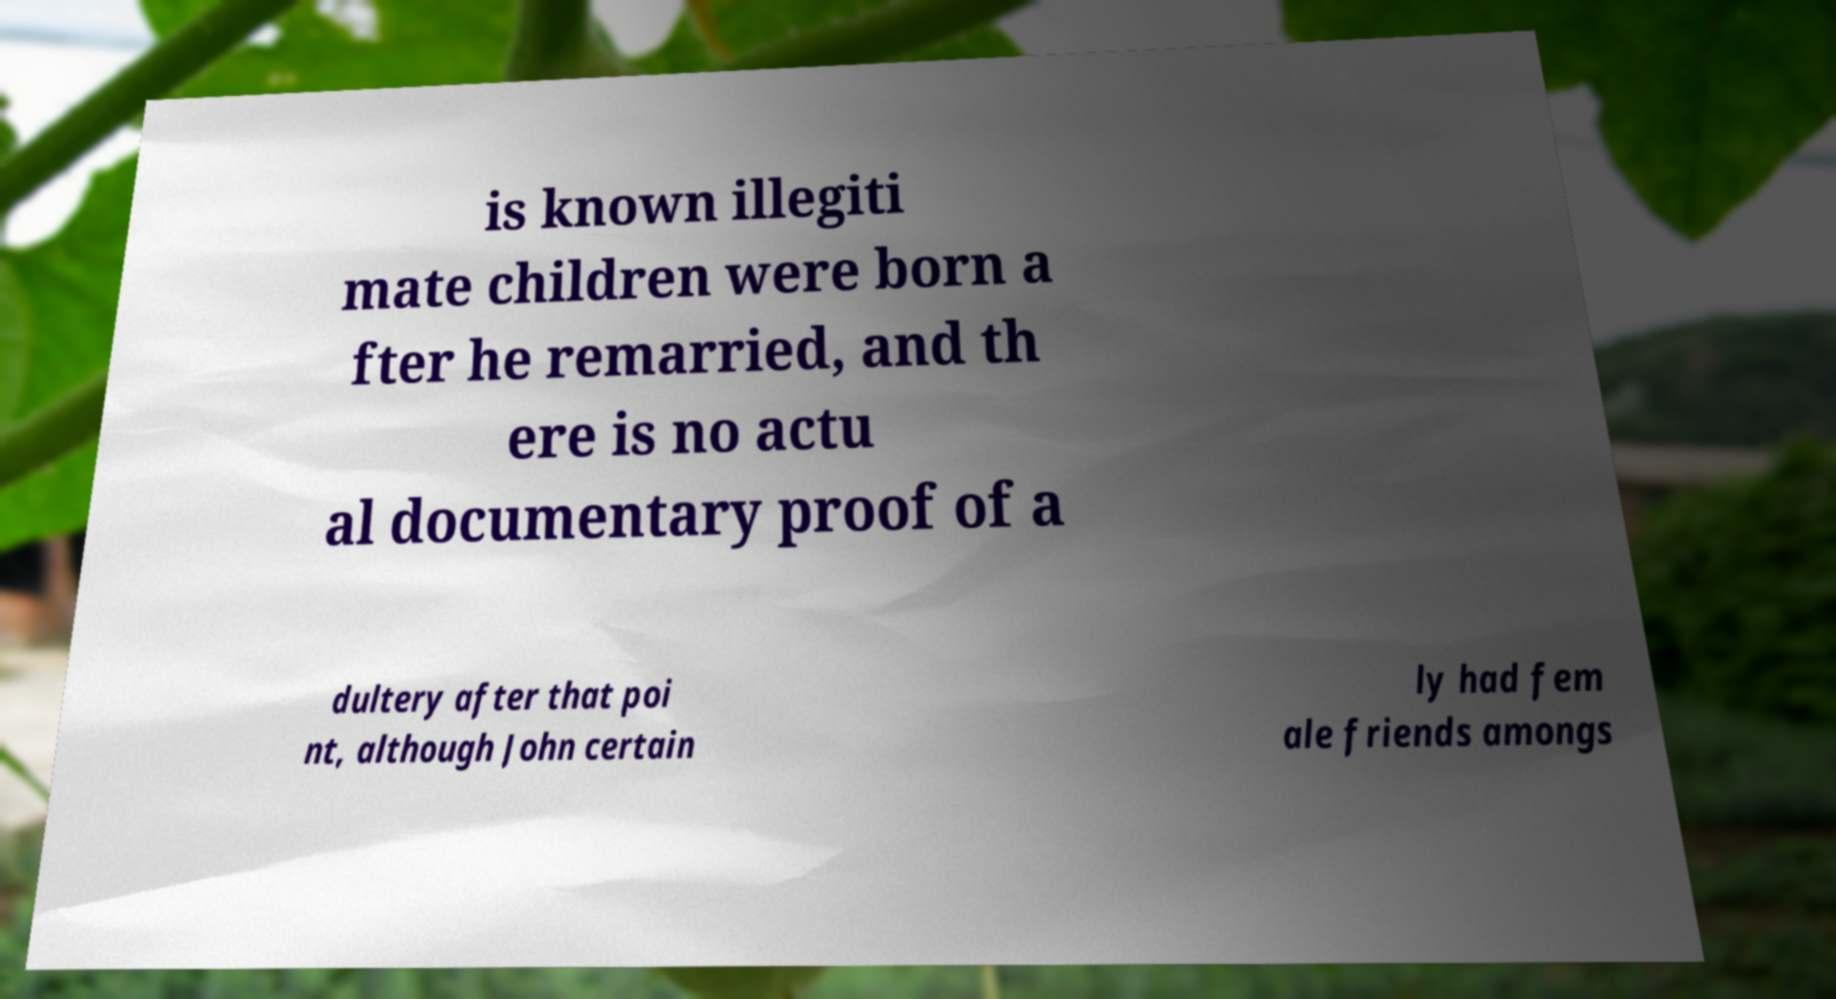Please identify and transcribe the text found in this image. is known illegiti mate children were born a fter he remarried, and th ere is no actu al documentary proof of a dultery after that poi nt, although John certain ly had fem ale friends amongs 